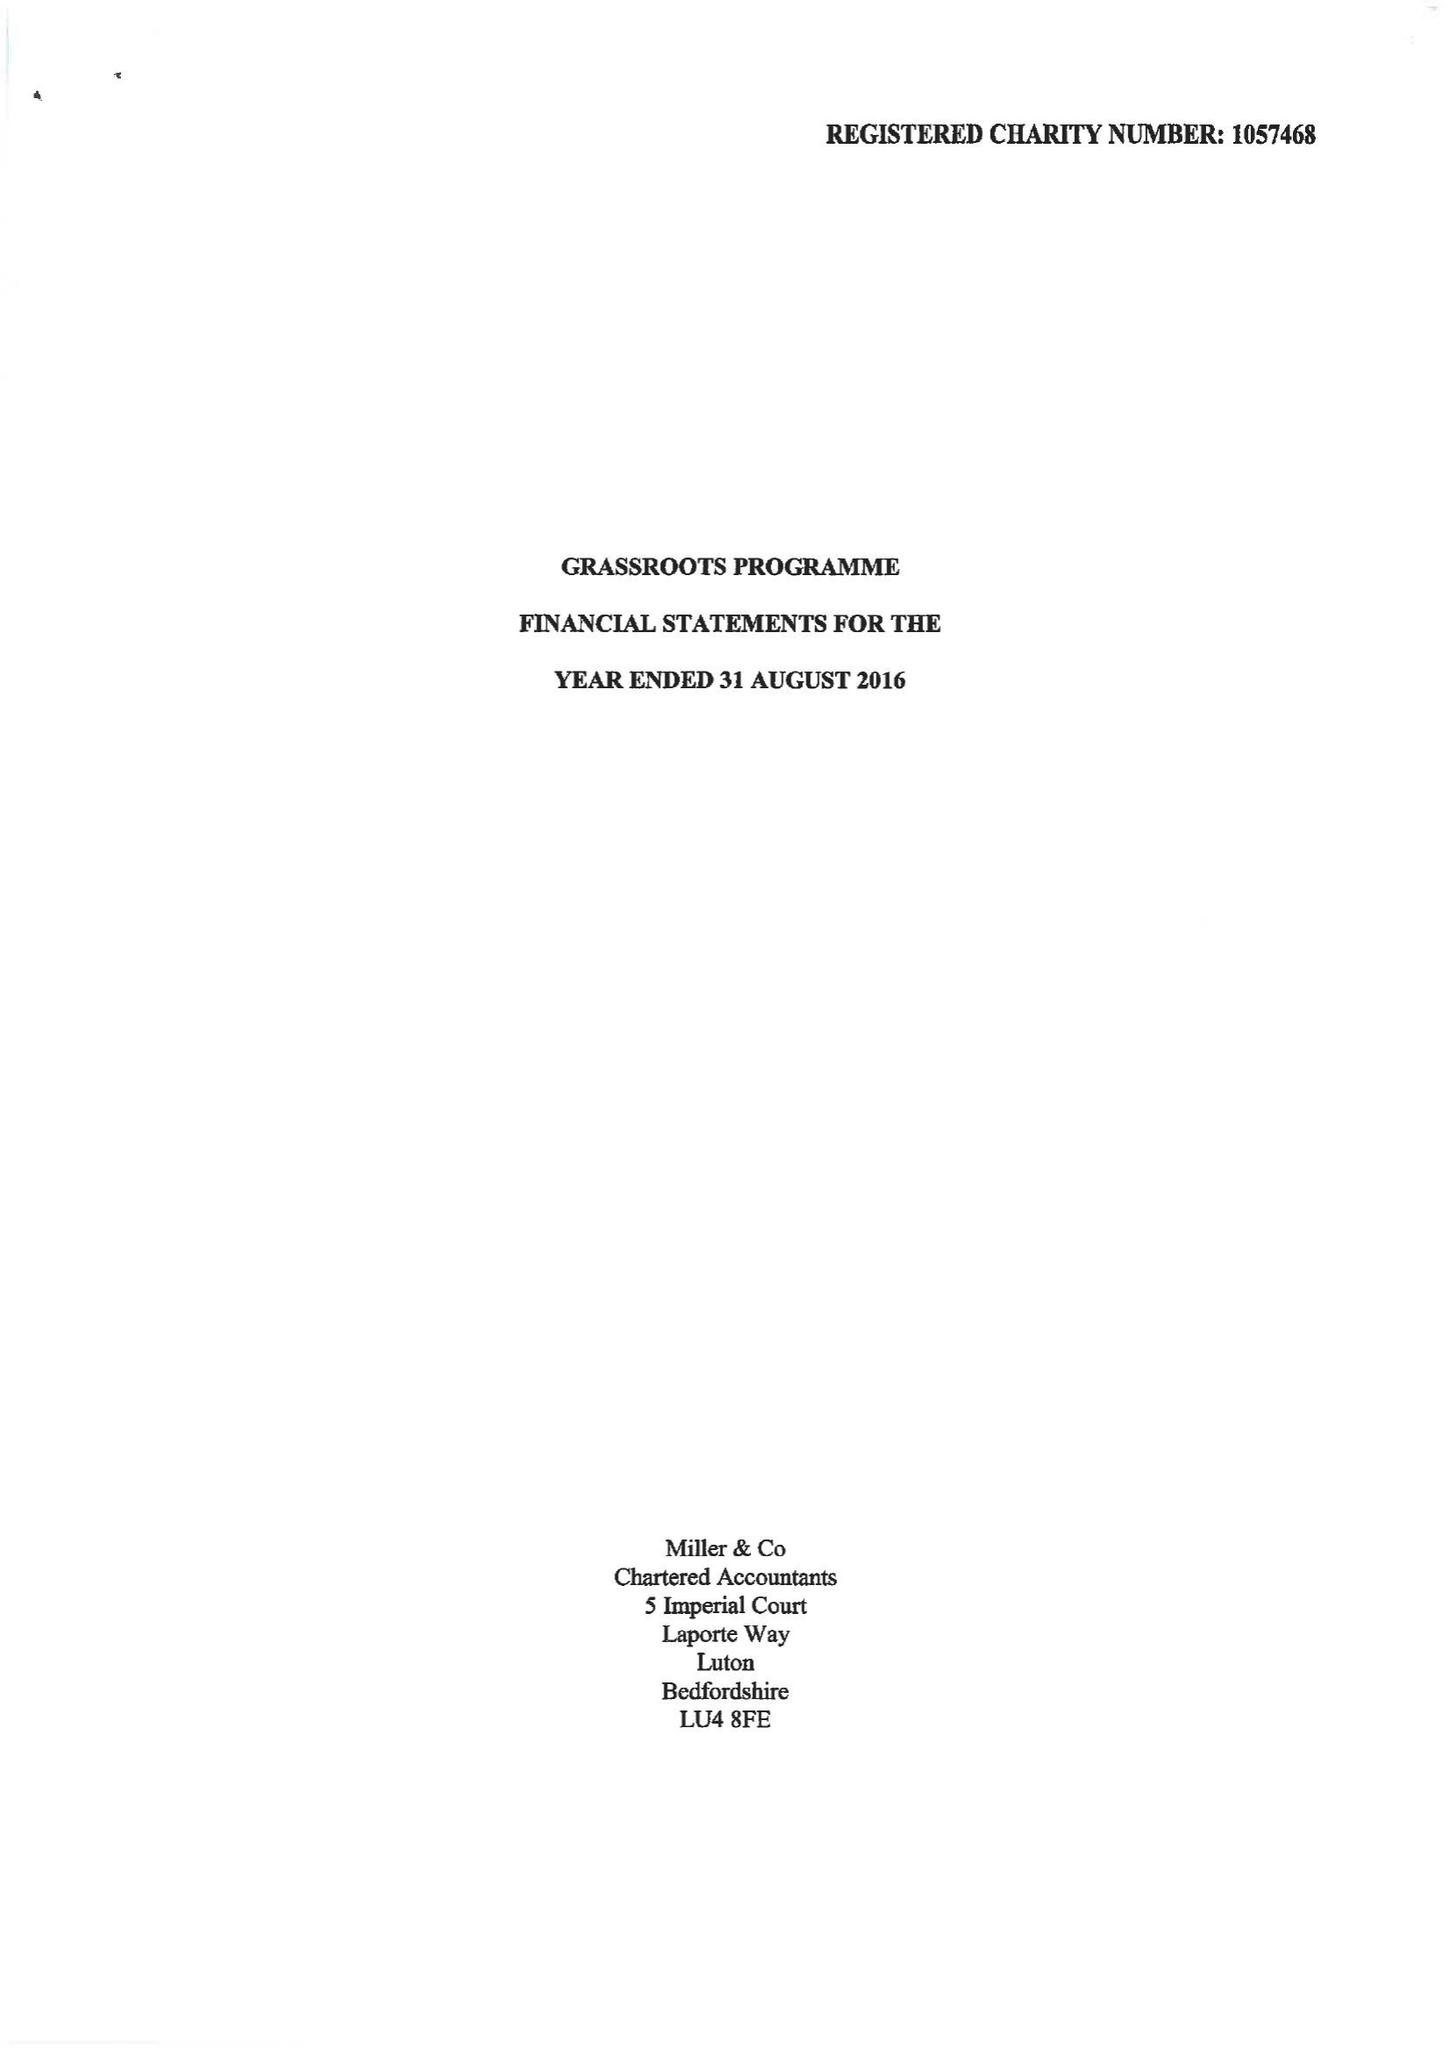What is the value for the charity_number?
Answer the question using a single word or phrase. 1163427 